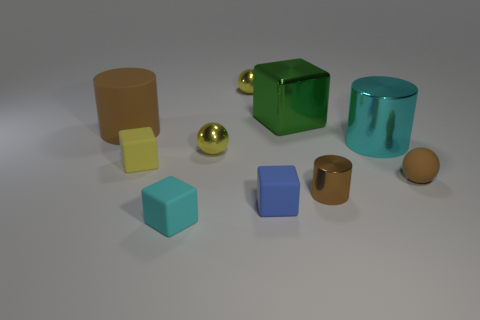What is the material of the sphere that is the same color as the large rubber cylinder?
Offer a very short reply. Rubber. How many cylinders are behind the brown rubber cylinder that is on the left side of the brown object to the right of the small metal cylinder?
Your response must be concise. 0. There is a brown sphere that is the same size as the blue matte object; what material is it?
Keep it short and to the point. Rubber. Are there any brown cylinders of the same size as the green thing?
Give a very brief answer. Yes. What is the color of the small cylinder?
Provide a succinct answer. Brown. What color is the cylinder in front of the brown rubber thing in front of the large cyan cylinder?
Your answer should be compact. Brown. What is the shape of the brown matte thing right of the block to the left of the cyan thing that is in front of the blue rubber cube?
Your answer should be very brief. Sphere. How many large brown cylinders are made of the same material as the green block?
Offer a terse response. 0. There is a small metal thing that is behind the big shiny cylinder; how many cyan metallic objects are behind it?
Ensure brevity in your answer.  0. What number of small metallic things are there?
Your response must be concise. 3. 